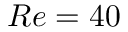Convert formula to latex. <formula><loc_0><loc_0><loc_500><loc_500>R e = 4 0</formula> 